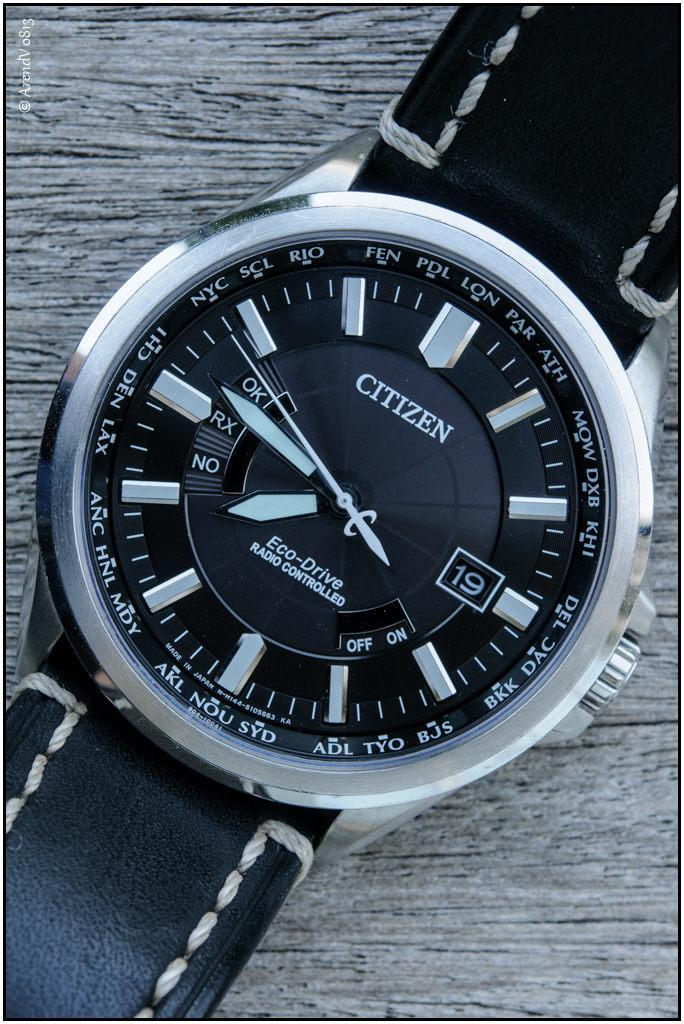<image>
Summarize the visual content of the image. Citizen is the brand of this high tech looking watch. 